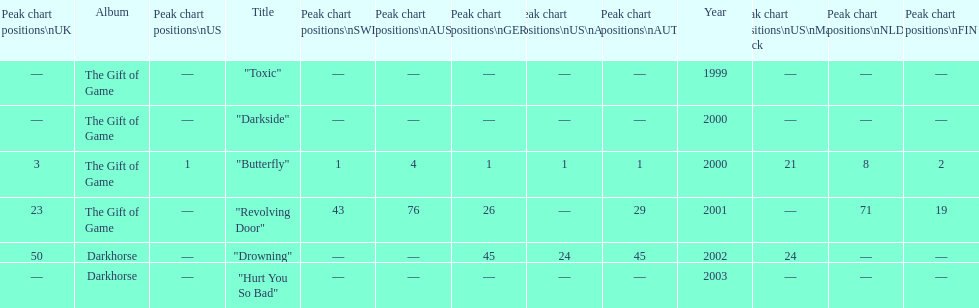By how many chart positions higher did "revolving door" peak in the uk compared to the peak position of "drowning" in the uk? 27. 